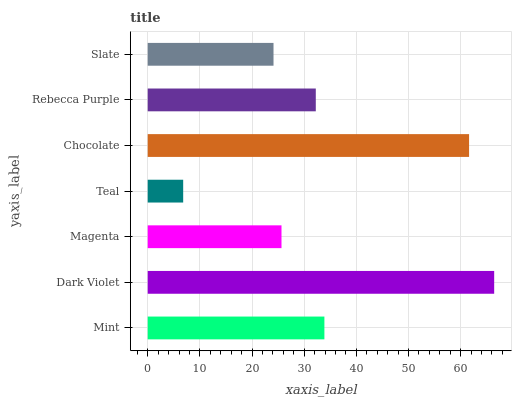Is Teal the minimum?
Answer yes or no. Yes. Is Dark Violet the maximum?
Answer yes or no. Yes. Is Magenta the minimum?
Answer yes or no. No. Is Magenta the maximum?
Answer yes or no. No. Is Dark Violet greater than Magenta?
Answer yes or no. Yes. Is Magenta less than Dark Violet?
Answer yes or no. Yes. Is Magenta greater than Dark Violet?
Answer yes or no. No. Is Dark Violet less than Magenta?
Answer yes or no. No. Is Rebecca Purple the high median?
Answer yes or no. Yes. Is Rebecca Purple the low median?
Answer yes or no. Yes. Is Slate the high median?
Answer yes or no. No. Is Dark Violet the low median?
Answer yes or no. No. 